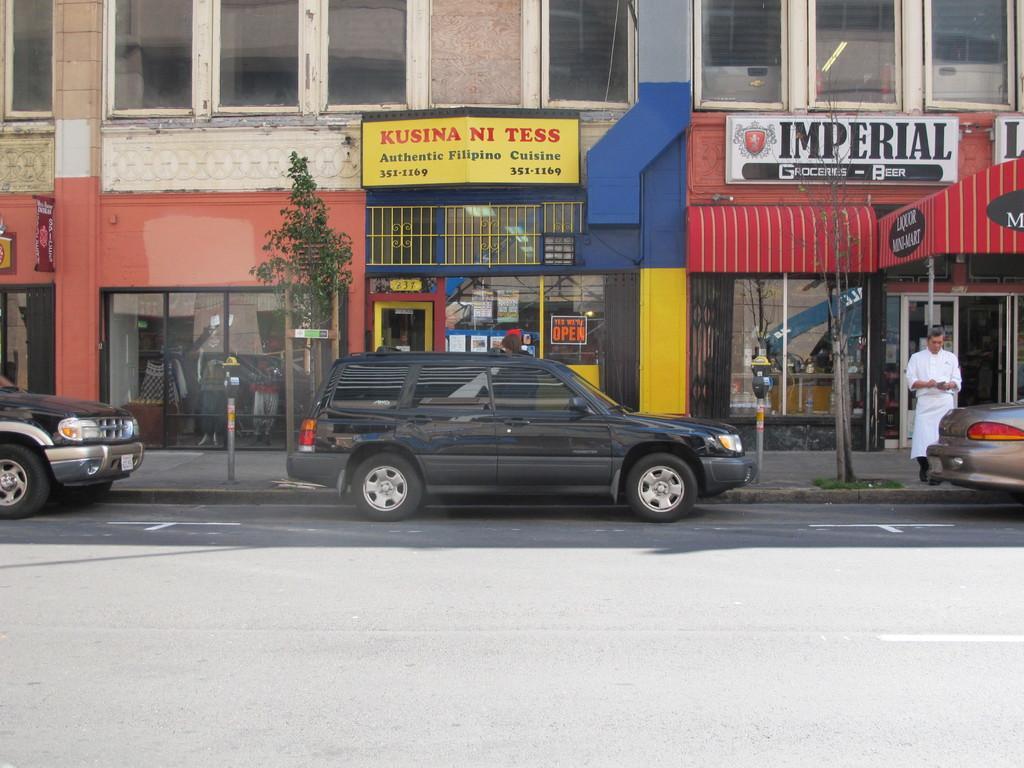Could you give a brief overview of what you see in this image? In this picture we can see a few vehicles in the building. There is a person on the path. We can see a building and few things in this building. 